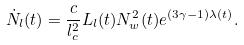Convert formula to latex. <formula><loc_0><loc_0><loc_500><loc_500>\dot { N } _ { l } ( t ) = \frac { c } { l _ { c } ^ { 2 } } L _ { l } ( t ) N _ { w } ^ { 2 } ( t ) e ^ { ( 3 \gamma - 1 ) \lambda ( t ) } .</formula> 